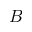<formula> <loc_0><loc_0><loc_500><loc_500>B</formula> 